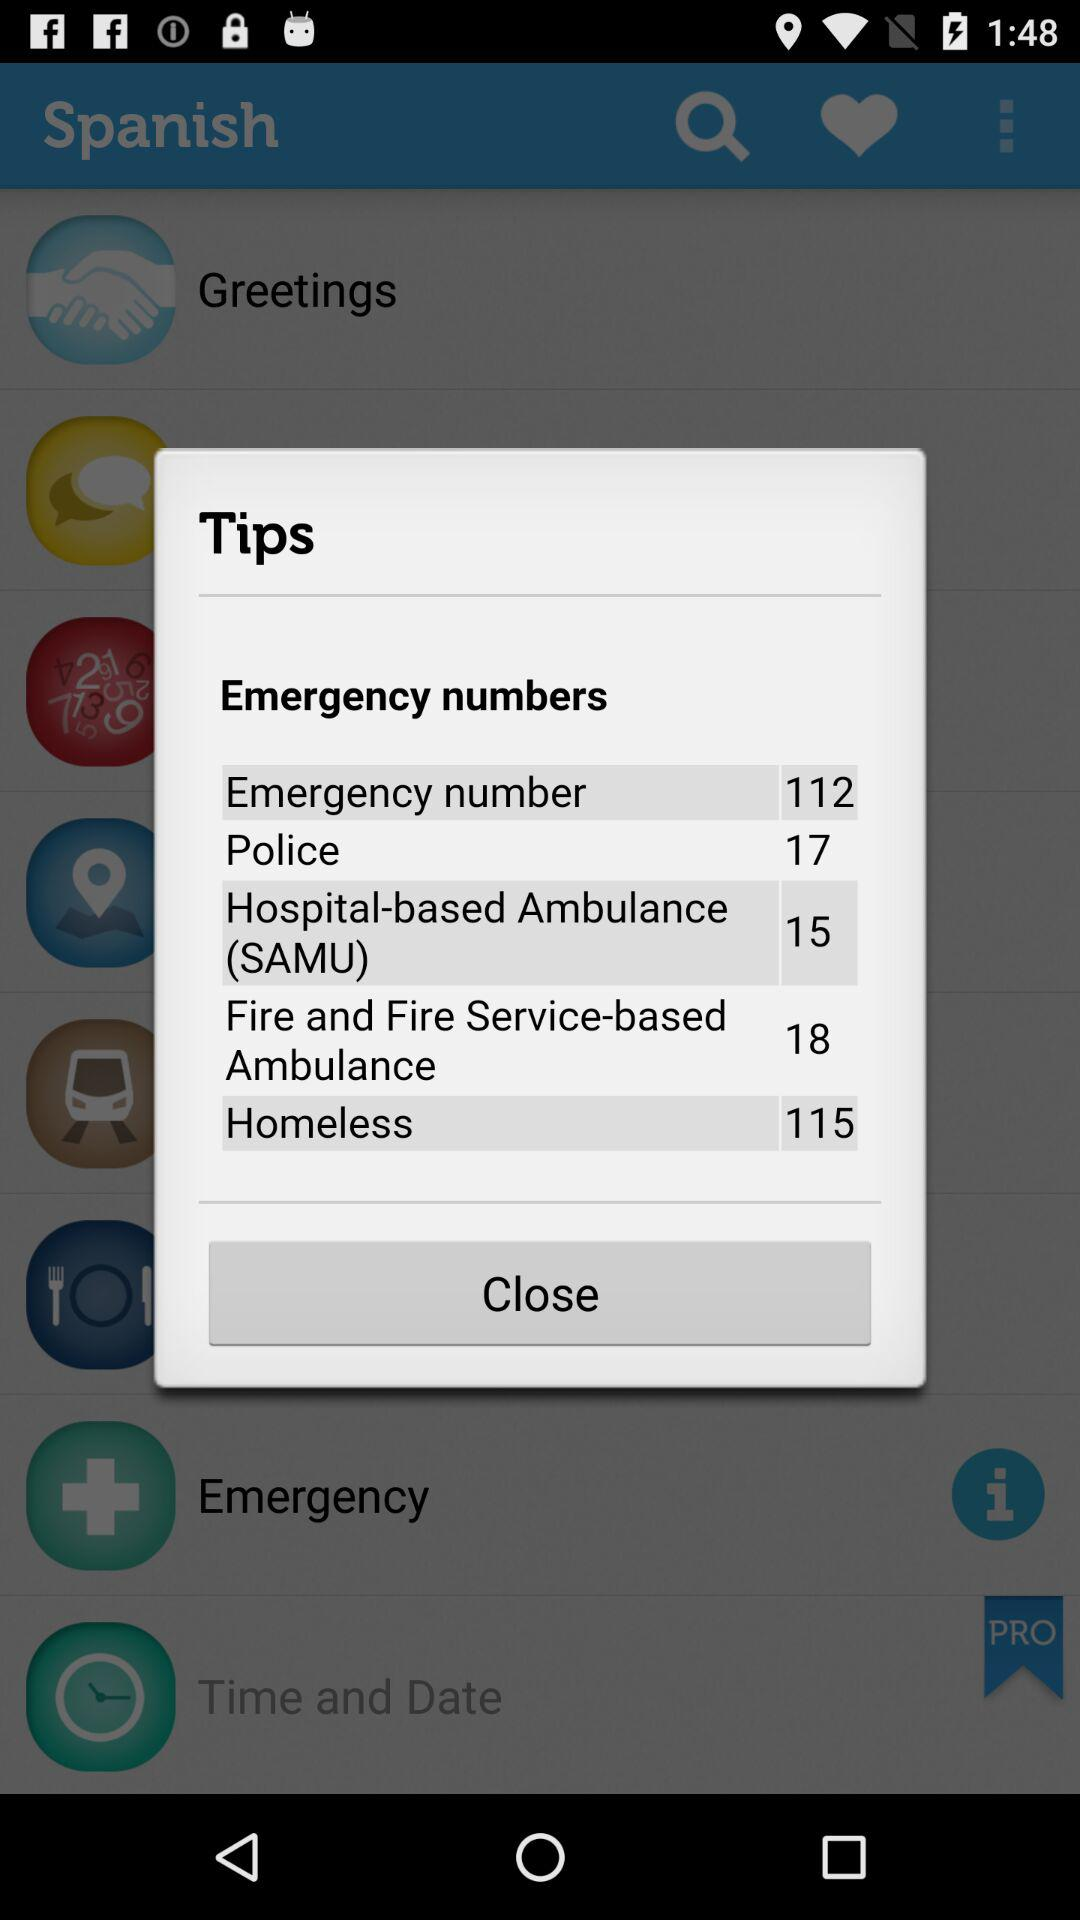What is the emergency number for hospital-based ambulances? The emergency number for hospital-based ambulances is 15. 